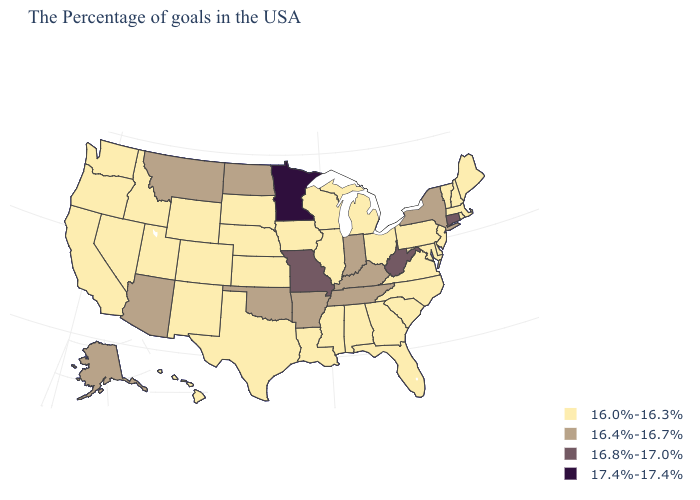Among the states that border Wyoming , does South Dakota have the highest value?
Short answer required. No. What is the value of Maryland?
Write a very short answer. 16.0%-16.3%. What is the lowest value in the West?
Write a very short answer. 16.0%-16.3%. Name the states that have a value in the range 16.8%-17.0%?
Answer briefly. Connecticut, West Virginia, Missouri. Name the states that have a value in the range 16.8%-17.0%?
Be succinct. Connecticut, West Virginia, Missouri. What is the lowest value in the USA?
Short answer required. 16.0%-16.3%. Name the states that have a value in the range 16.4%-16.7%?
Concise answer only. New York, Kentucky, Indiana, Tennessee, Arkansas, Oklahoma, North Dakota, Montana, Arizona, Alaska. Does Georgia have the same value as Maine?
Be succinct. Yes. Does Pennsylvania have a higher value than Indiana?
Answer briefly. No. What is the value of Wisconsin?
Keep it brief. 16.0%-16.3%. Which states have the lowest value in the West?
Quick response, please. Wyoming, Colorado, New Mexico, Utah, Idaho, Nevada, California, Washington, Oregon, Hawaii. What is the value of Idaho?
Concise answer only. 16.0%-16.3%. Does the first symbol in the legend represent the smallest category?
Give a very brief answer. Yes. What is the highest value in the Northeast ?
Keep it brief. 16.8%-17.0%. Name the states that have a value in the range 16.8%-17.0%?
Short answer required. Connecticut, West Virginia, Missouri. 